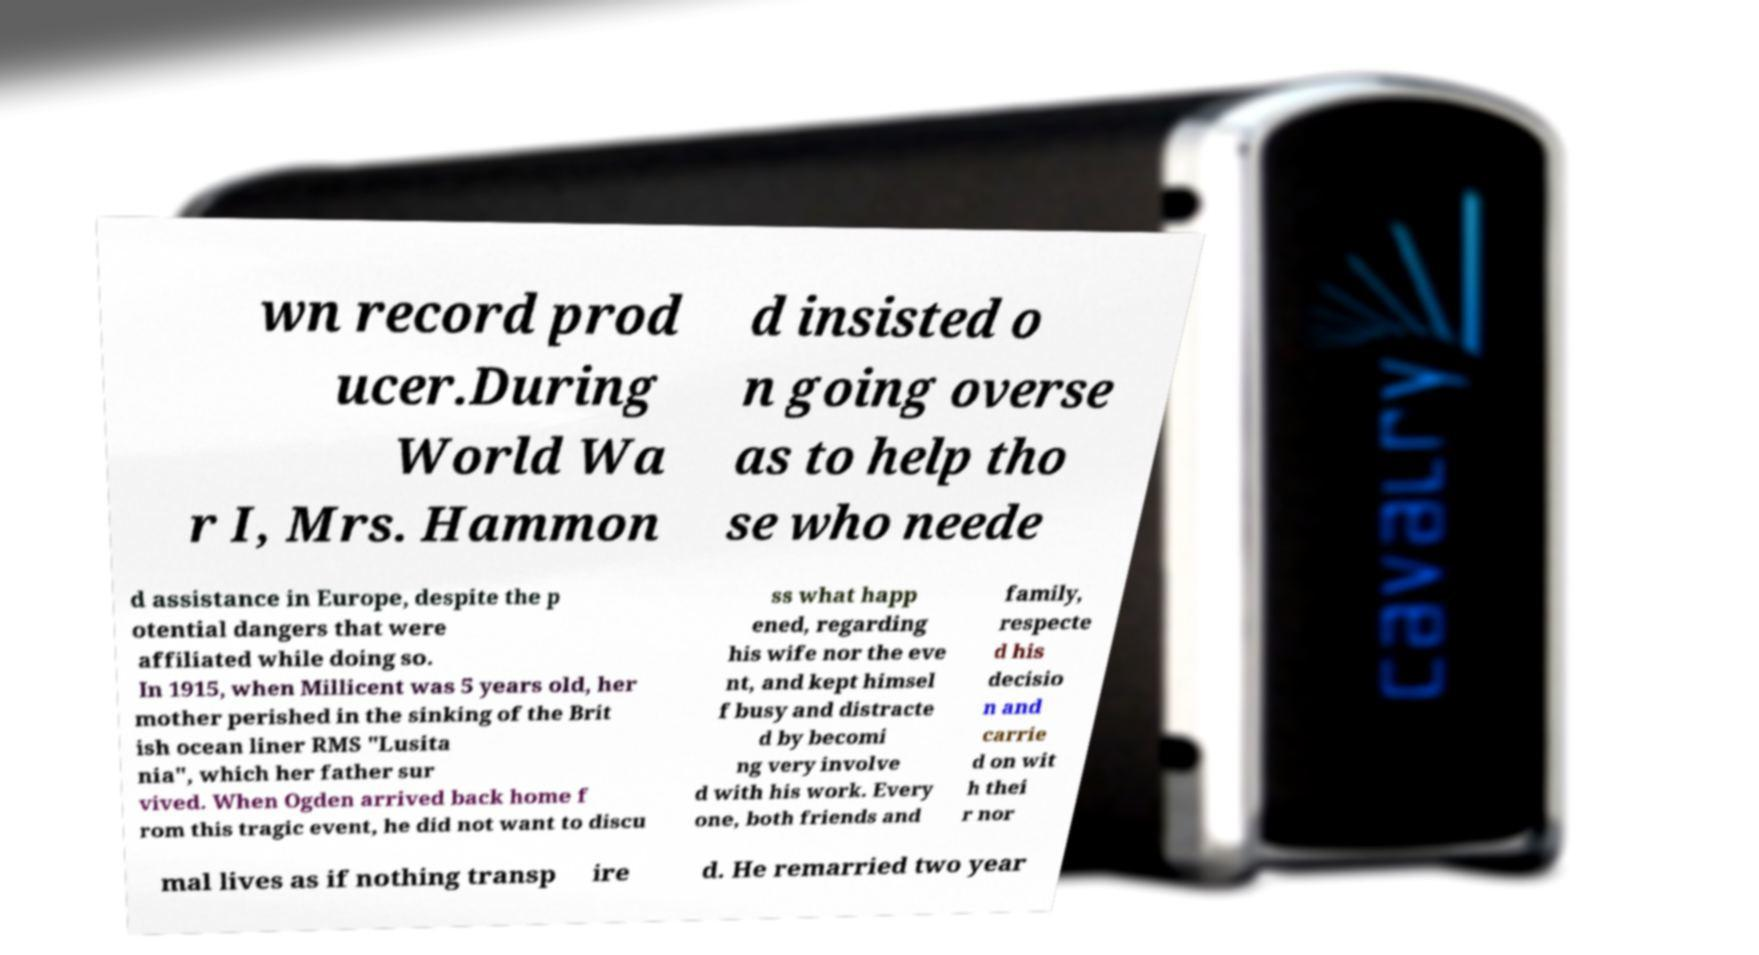What messages or text are displayed in this image? I need them in a readable, typed format. wn record prod ucer.During World Wa r I, Mrs. Hammon d insisted o n going overse as to help tho se who neede d assistance in Europe, despite the p otential dangers that were affiliated while doing so. In 1915, when Millicent was 5 years old, her mother perished in the sinking of the Brit ish ocean liner RMS "Lusita nia", which her father sur vived. When Ogden arrived back home f rom this tragic event, he did not want to discu ss what happ ened, regarding his wife nor the eve nt, and kept himsel f busy and distracte d by becomi ng very involve d with his work. Every one, both friends and family, respecte d his decisio n and carrie d on wit h thei r nor mal lives as if nothing transp ire d. He remarried two year 